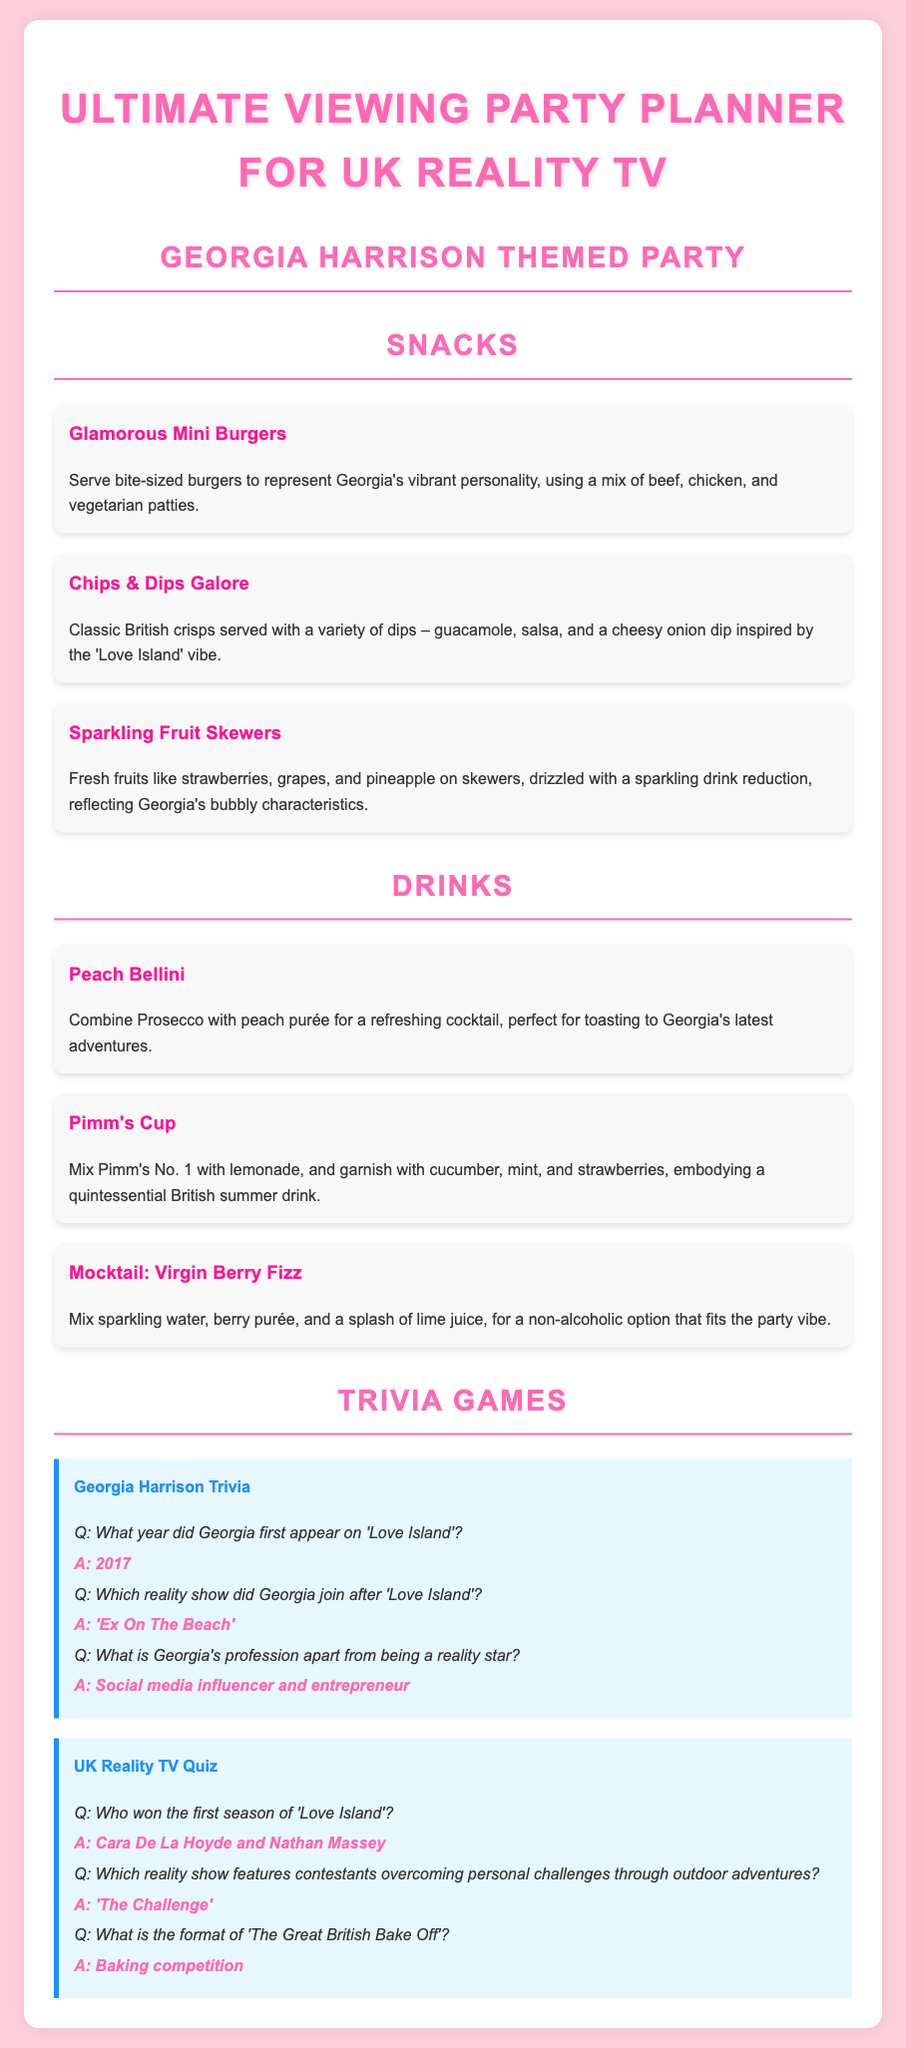What is the title of the document? The title of the document is listed in the header section, which is "Ultimate Viewing Party Planner for UK Reality TV."
Answer: Ultimate Viewing Party Planner for UK Reality TV What is one snack included in the menu? The document lists different snacks in the snacks section; one mentioned is "Glamorous Mini Burgers."
Answer: Glamorous Mini Burgers What type of drink is recommended for the party? The drinks section includes several drink options; one mentioned is "Peach Bellini."
Answer: Peach Bellini In which year did Georgia first appear on 'Love Island'? The trivia section specifically mentions the year of Georgia's appearance on 'Love Island,' which is 2017.
Answer: 2017 What is Georgia's profession aside from being a reality star? The document indicates that Georgia's profession includes being a "social media influencer and entrepreneur."
Answer: Social media influencer and entrepreneur What is the drink composition of a Pimm's Cup? The drink's ingredients are listed in the drinks section, mentioning that it mixes Pimm's No. 1 with lemonade, garnished with cucumber, mint, and strawberries.
Answer: Pimm's No. 1 with lemonade Who won the first season of 'Love Island'? The trivia section has a question about the winners of the first season and provides the answer as "Cara De La Hoyde and Nathan Massey."
Answer: Cara De La Hoyde and Nathan Massey Which reality show features outdoor adventures? The document states that the reality show featuring contestants overcoming personal challenges through outdoor adventures is "The Challenge."
Answer: The Challenge 